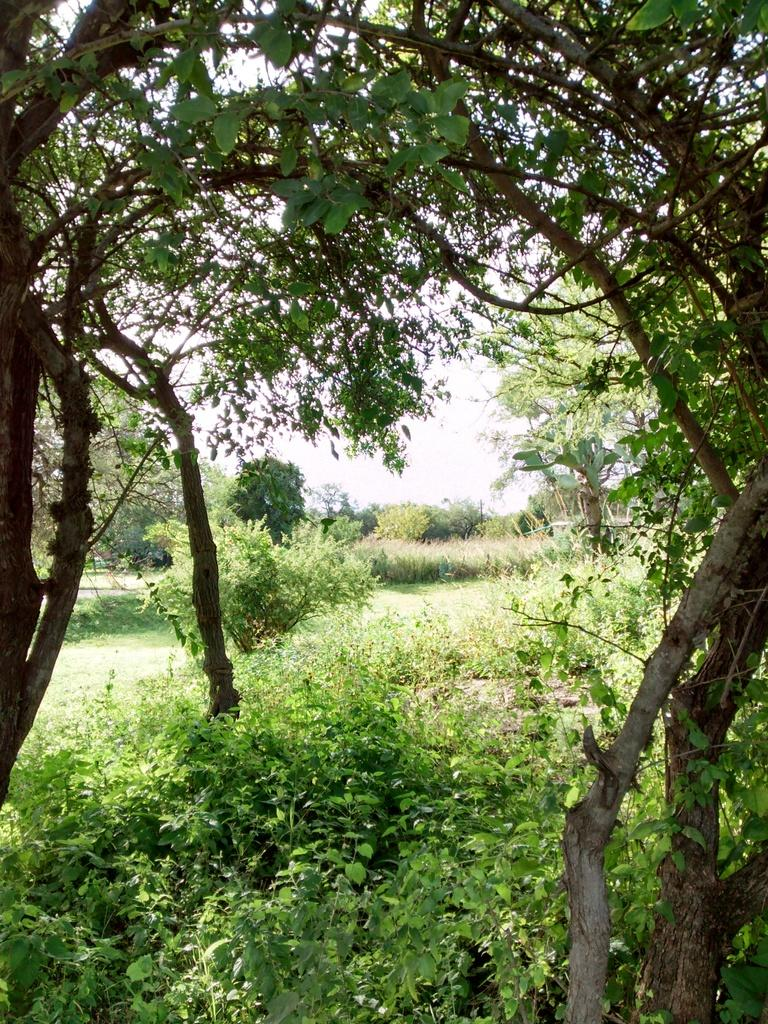What type of vegetation can be seen in the image? There are trees and plants in the image. What part of the natural environment is visible in the image? The sky is visible in the image. Can you describe the vegetation in the image? The trees and plants in the image are likely part of a natural landscape or garden. How many shelves are visible in the image? There are no shelves present in the image. What point is being made by the plants in the image? The plants in the image are not making any point; they are simply part of the natural landscape. 